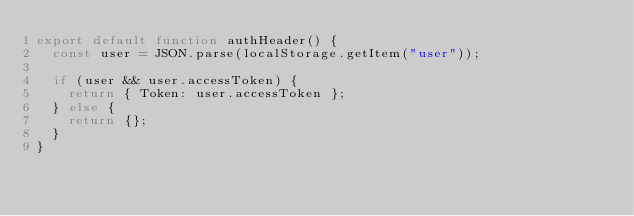Convert code to text. <code><loc_0><loc_0><loc_500><loc_500><_JavaScript_>export default function authHeader() {
  const user = JSON.parse(localStorage.getItem("user"));

  if (user && user.accessToken) {
    return { Token: user.accessToken };
  } else {
    return {};
  }
}
</code> 